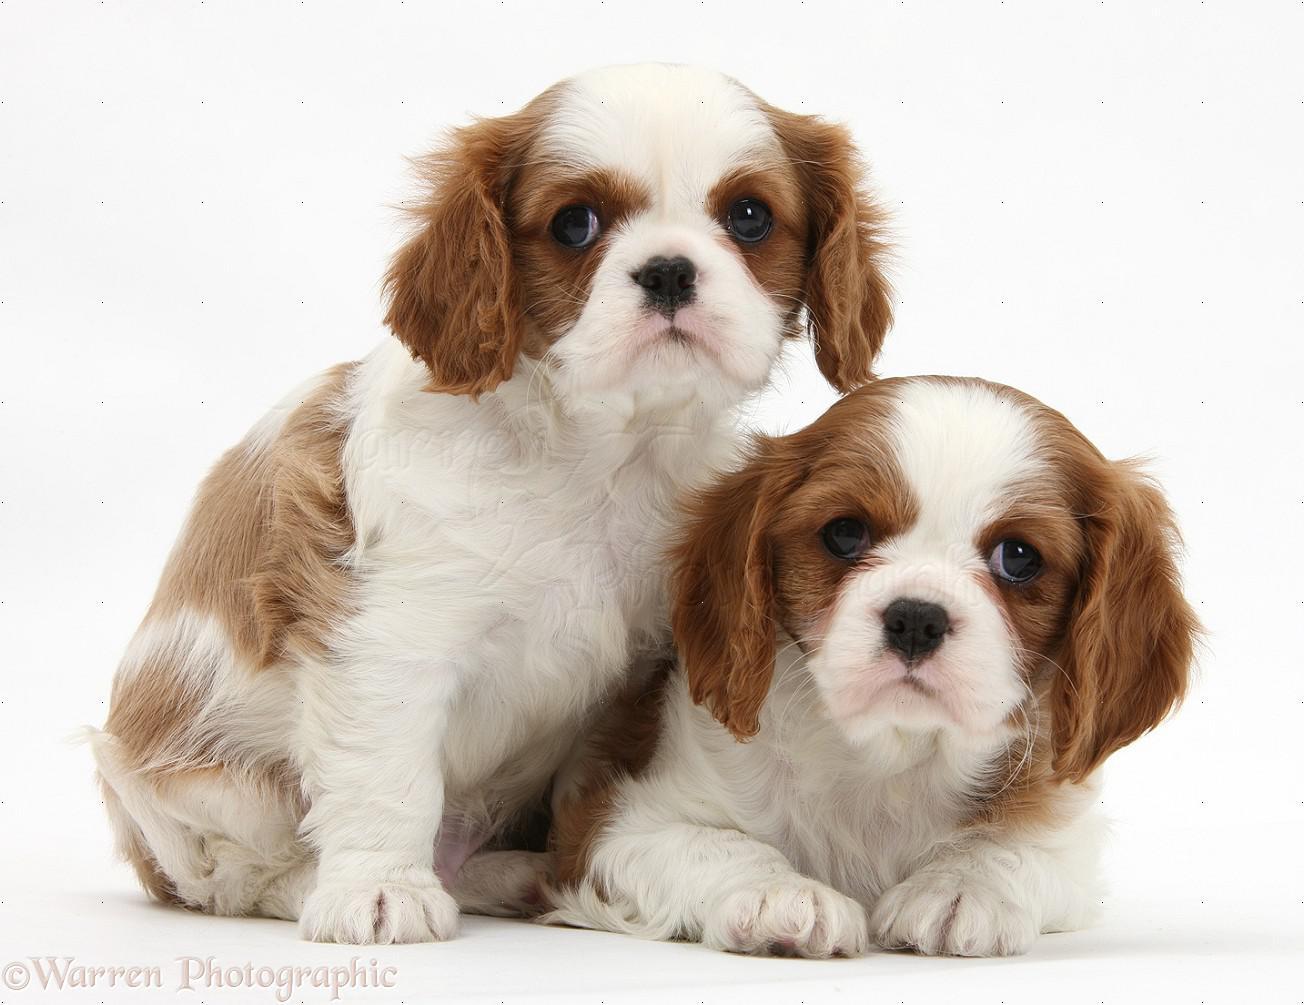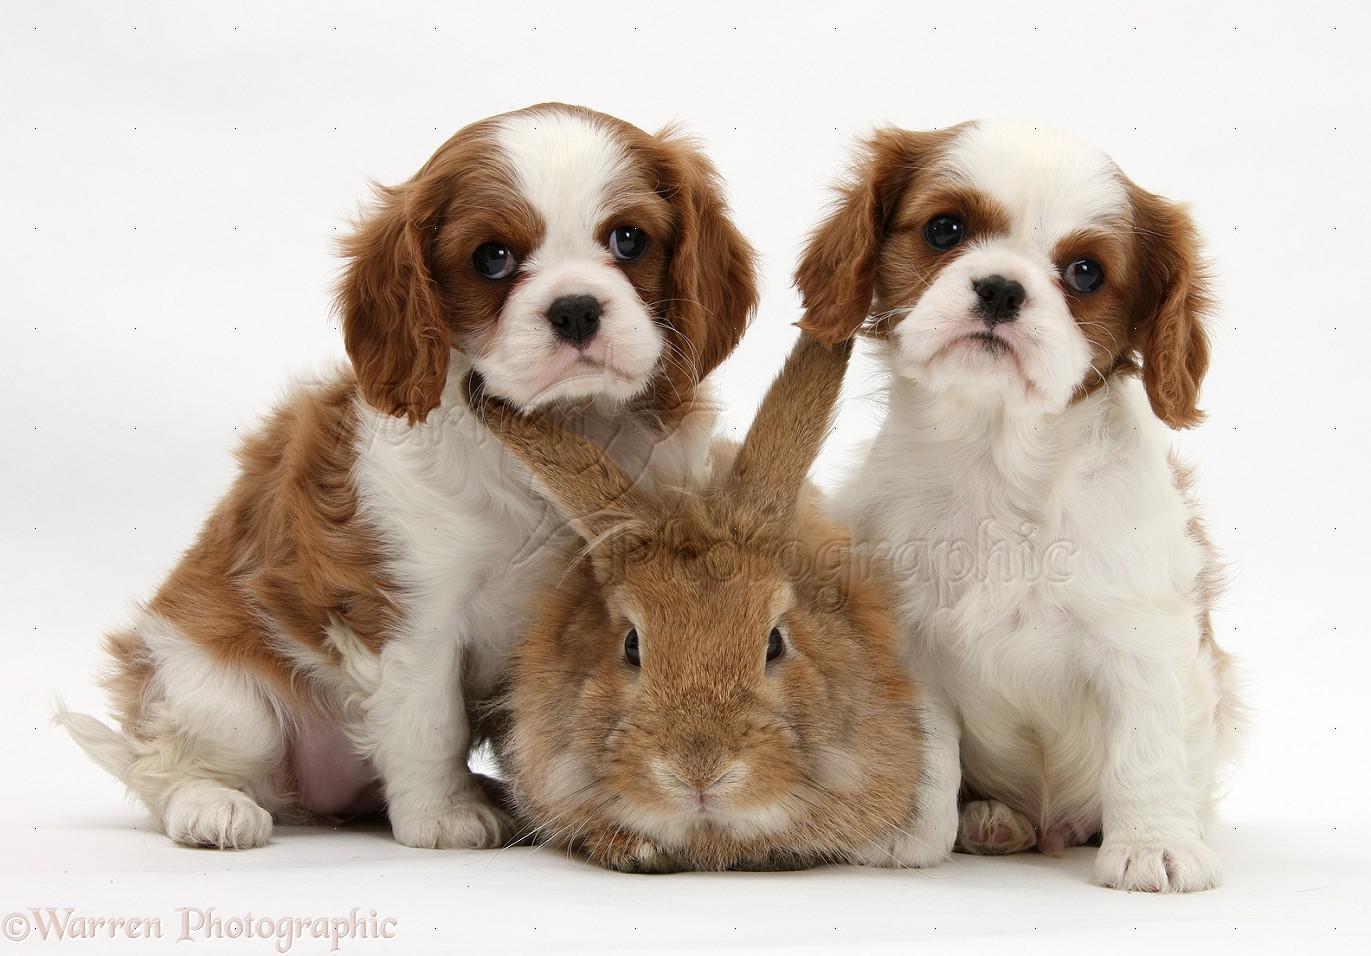The first image is the image on the left, the second image is the image on the right. Evaluate the accuracy of this statement regarding the images: "A rabbit is with at least one puppy.". Is it true? Answer yes or no. Yes. 